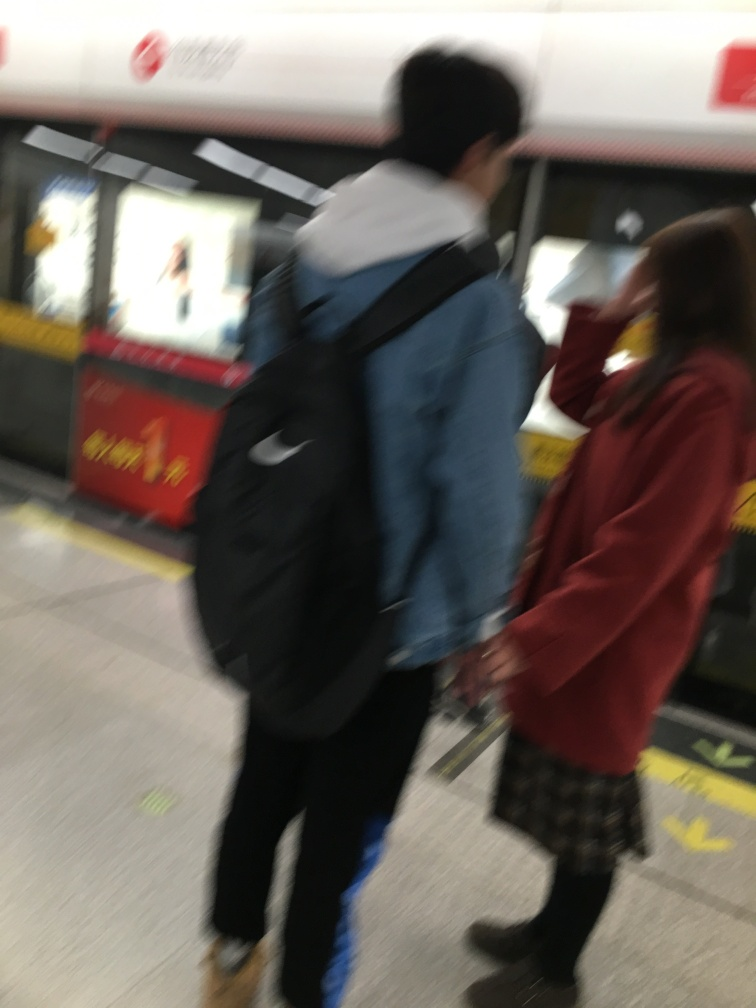Do the individuals in the image appear to be engaging with each other or the environment in any particular way? Although details are hard to make out, the two individuals seem to be turned towards each other, possibly conversing or interacting as they move through the station. The close proximity implies a social connection. 